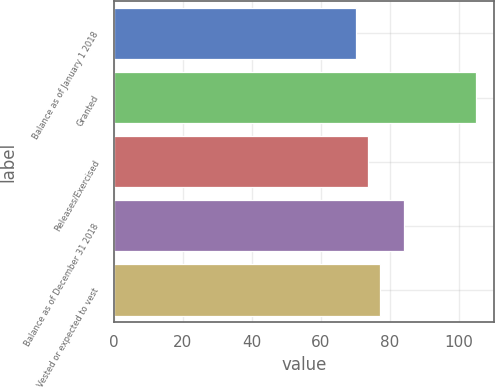Convert chart to OTSL. <chart><loc_0><loc_0><loc_500><loc_500><bar_chart><fcel>Balance as of January 1 2018<fcel>Granted<fcel>Releases/Exercised<fcel>Balance as of December 31 2018<fcel>Vested or expected to vest<nl><fcel>70<fcel>105<fcel>73.5<fcel>84<fcel>77<nl></chart> 